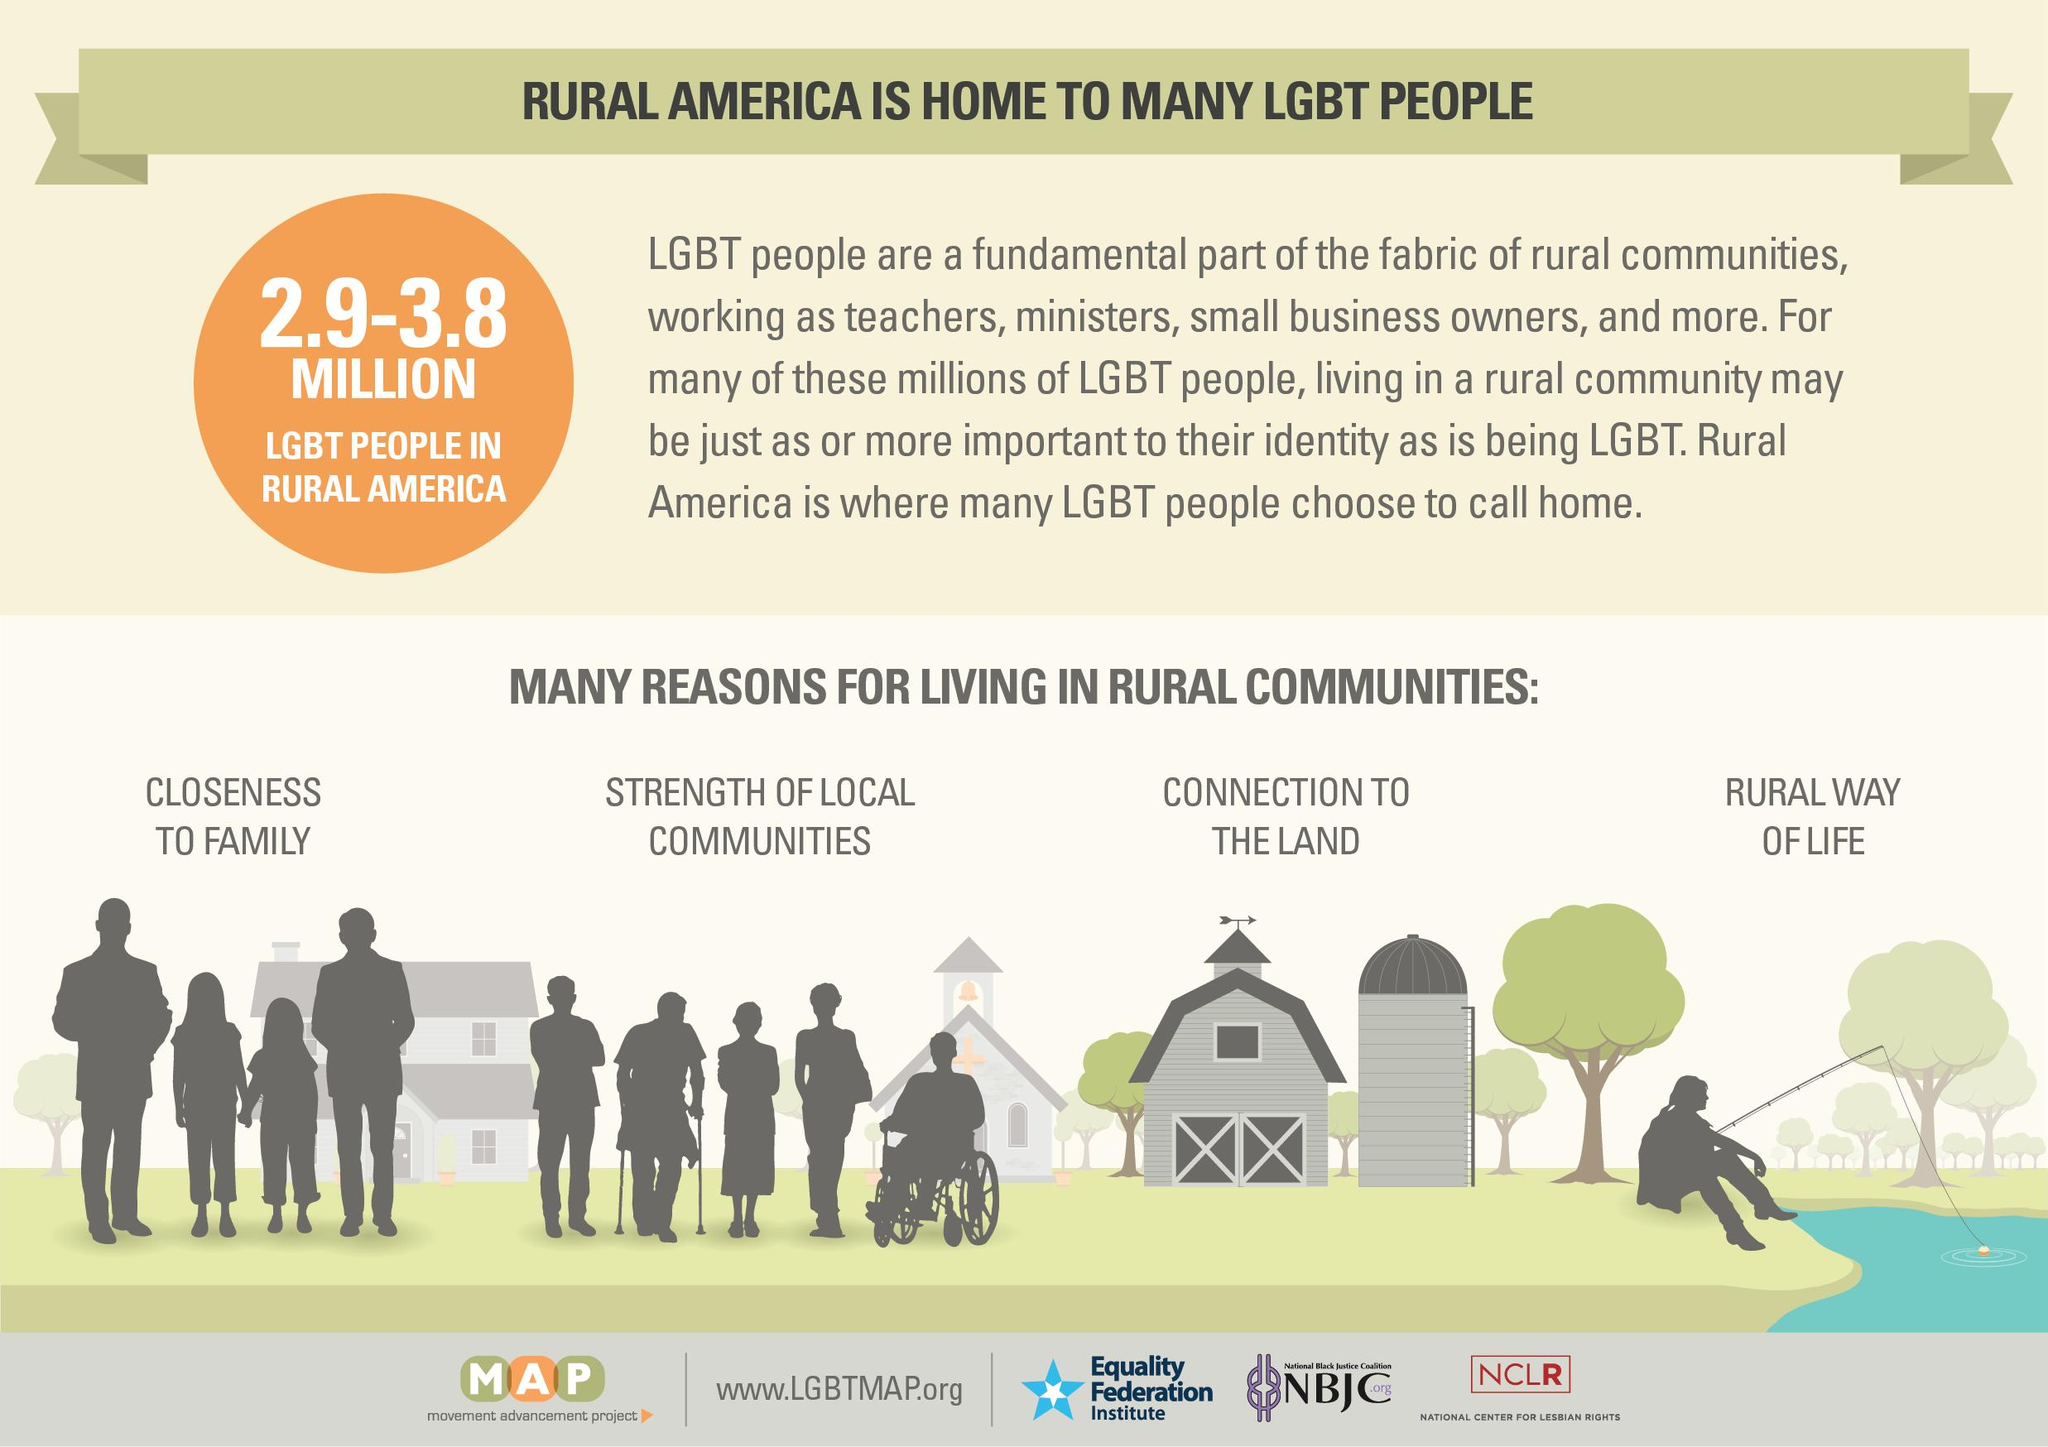Point out several critical features in this image. According to a recent study, the population of LGBT individuals in rural America is estimated to be between 2.9 million and 3.8 million. 